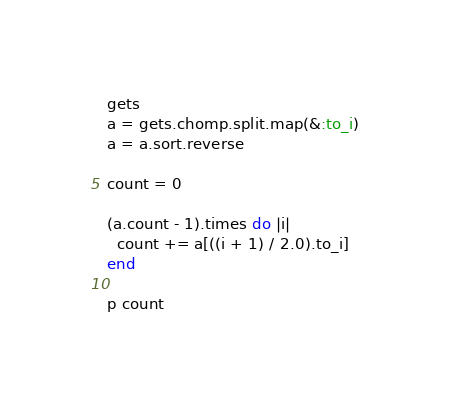Convert code to text. <code><loc_0><loc_0><loc_500><loc_500><_Ruby_>gets
a = gets.chomp.split.map(&:to_i)
a = a.sort.reverse

count = 0

(a.count - 1).times do |i|
  count += a[((i + 1) / 2.0).to_i]
end

p count
</code> 